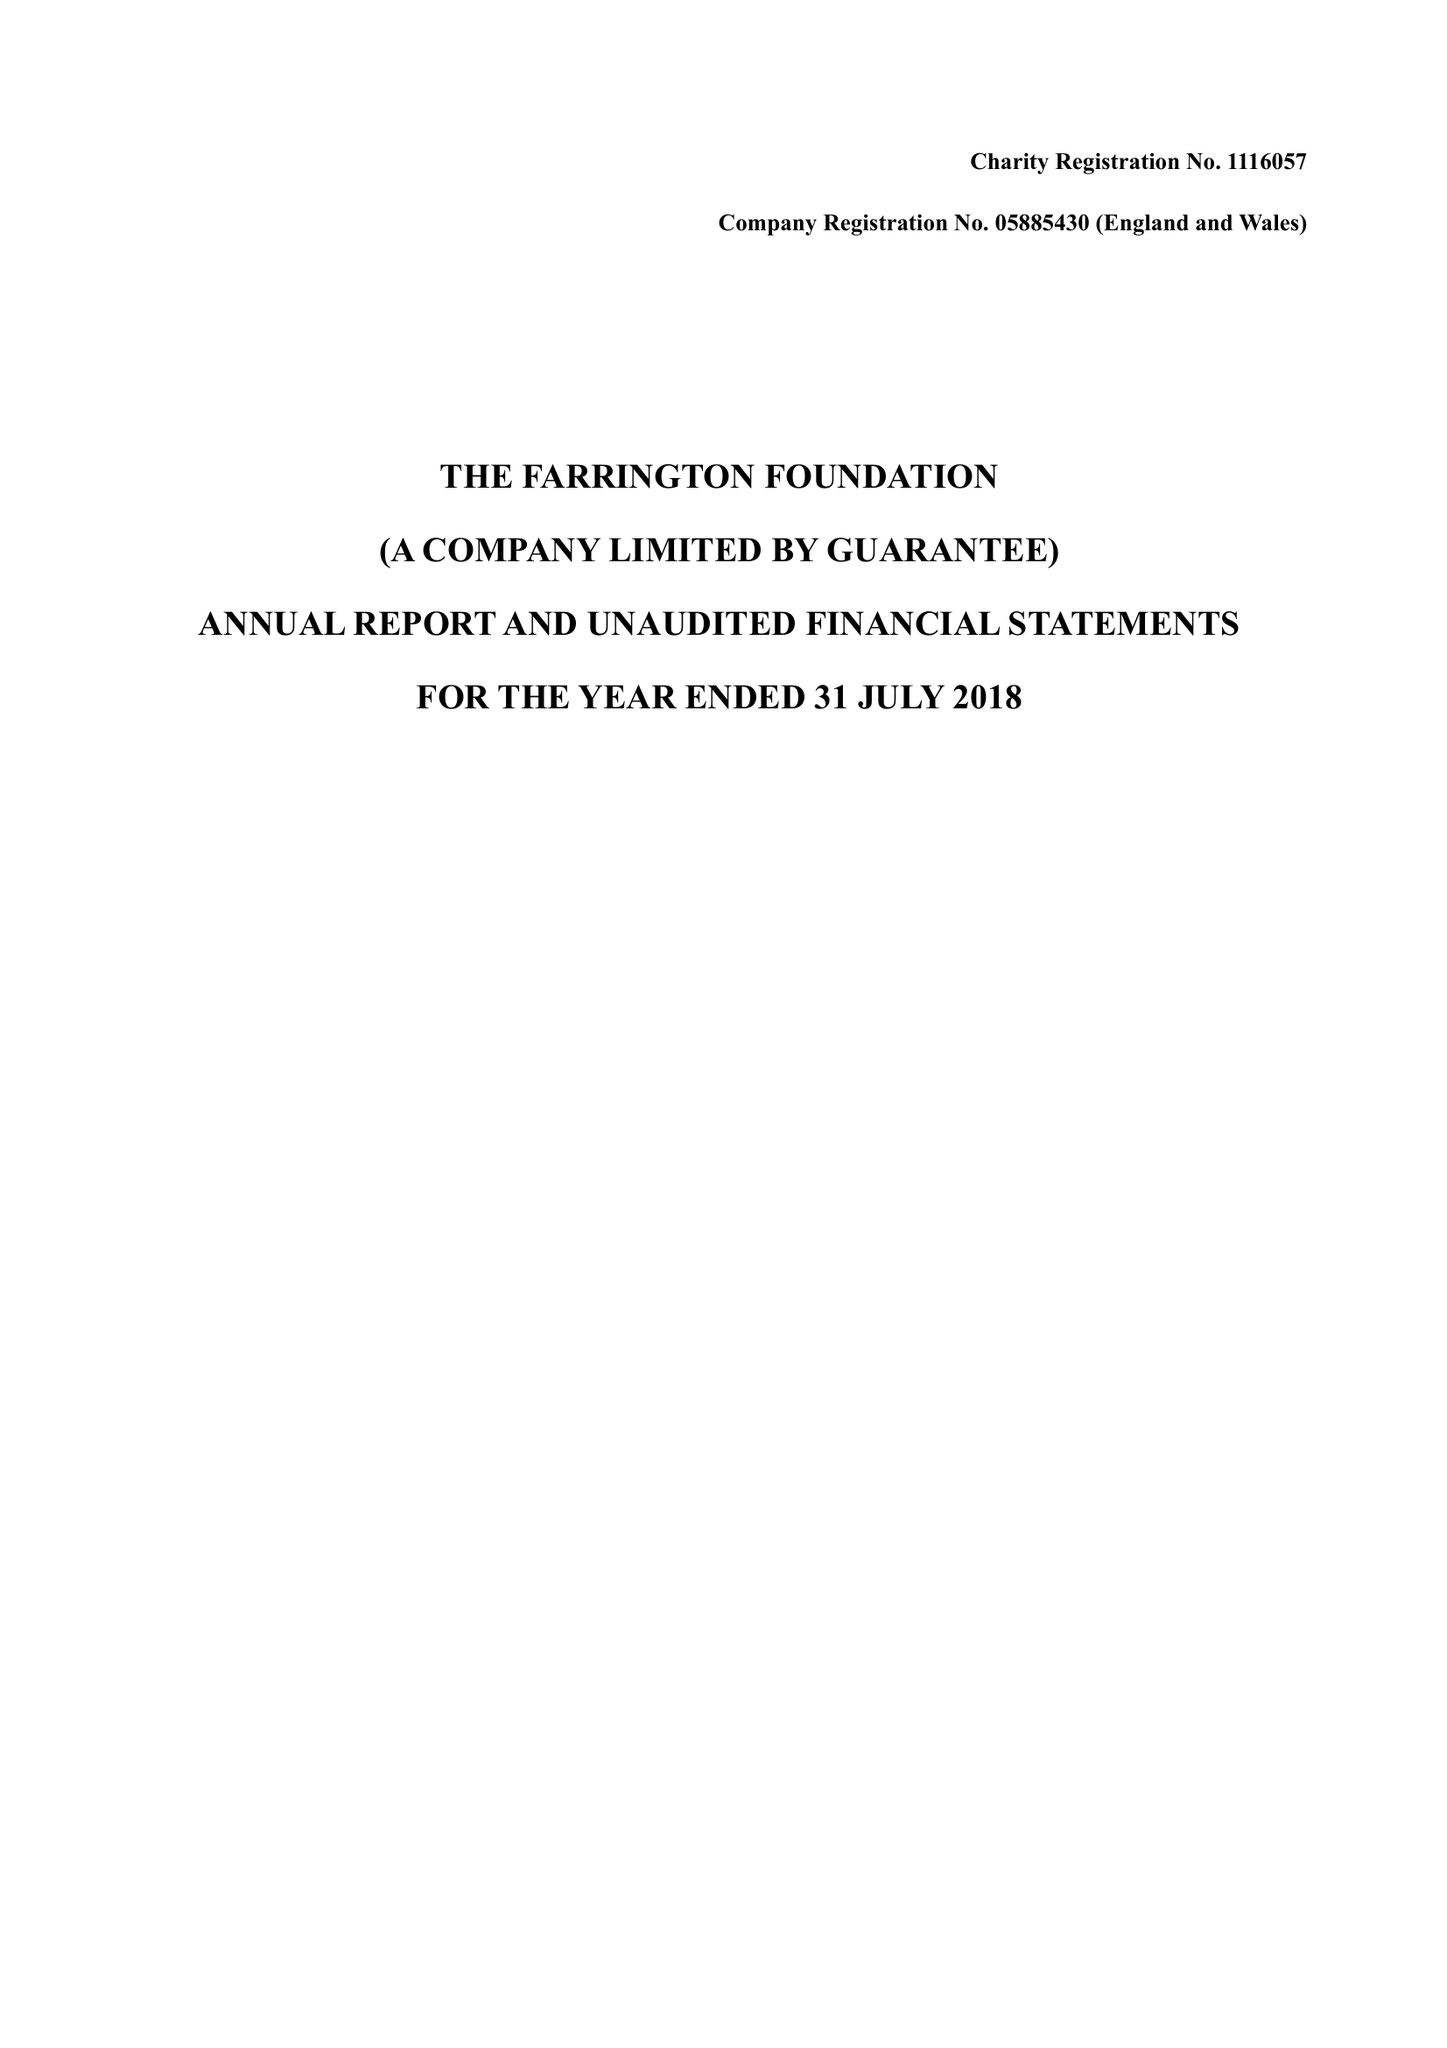What is the value for the spending_annually_in_british_pounds?
Answer the question using a single word or phrase. 23947.00 